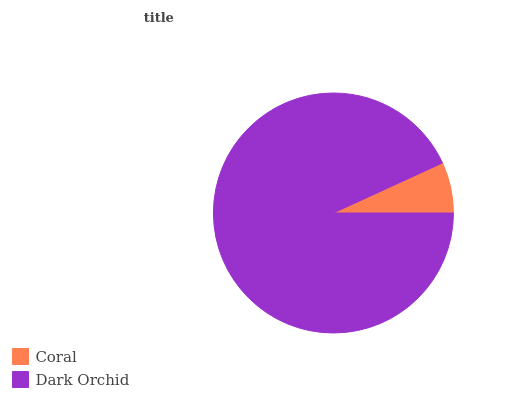Is Coral the minimum?
Answer yes or no. Yes. Is Dark Orchid the maximum?
Answer yes or no. Yes. Is Dark Orchid the minimum?
Answer yes or no. No. Is Dark Orchid greater than Coral?
Answer yes or no. Yes. Is Coral less than Dark Orchid?
Answer yes or no. Yes. Is Coral greater than Dark Orchid?
Answer yes or no. No. Is Dark Orchid less than Coral?
Answer yes or no. No. Is Dark Orchid the high median?
Answer yes or no. Yes. Is Coral the low median?
Answer yes or no. Yes. Is Coral the high median?
Answer yes or no. No. Is Dark Orchid the low median?
Answer yes or no. No. 